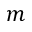Convert formula to latex. <formula><loc_0><loc_0><loc_500><loc_500>m</formula> 